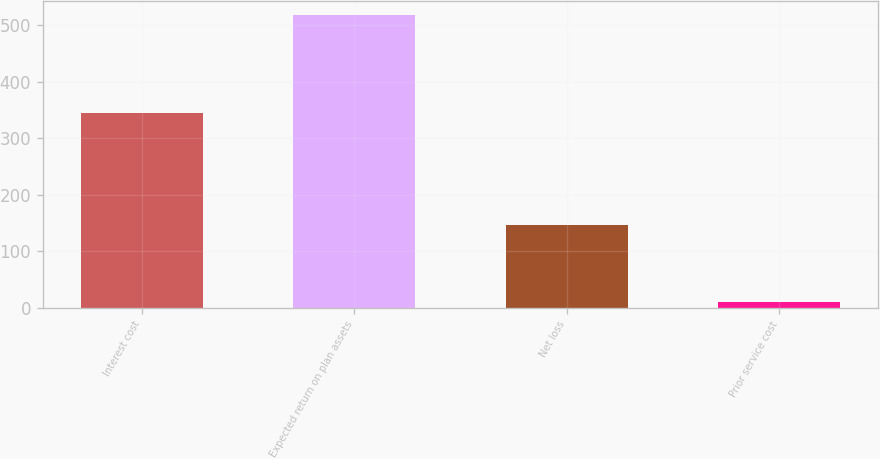<chart> <loc_0><loc_0><loc_500><loc_500><bar_chart><fcel>Interest cost<fcel>Expected return on plan assets<fcel>Net loss<fcel>Prior service cost<nl><fcel>345<fcel>518<fcel>147<fcel>10<nl></chart> 